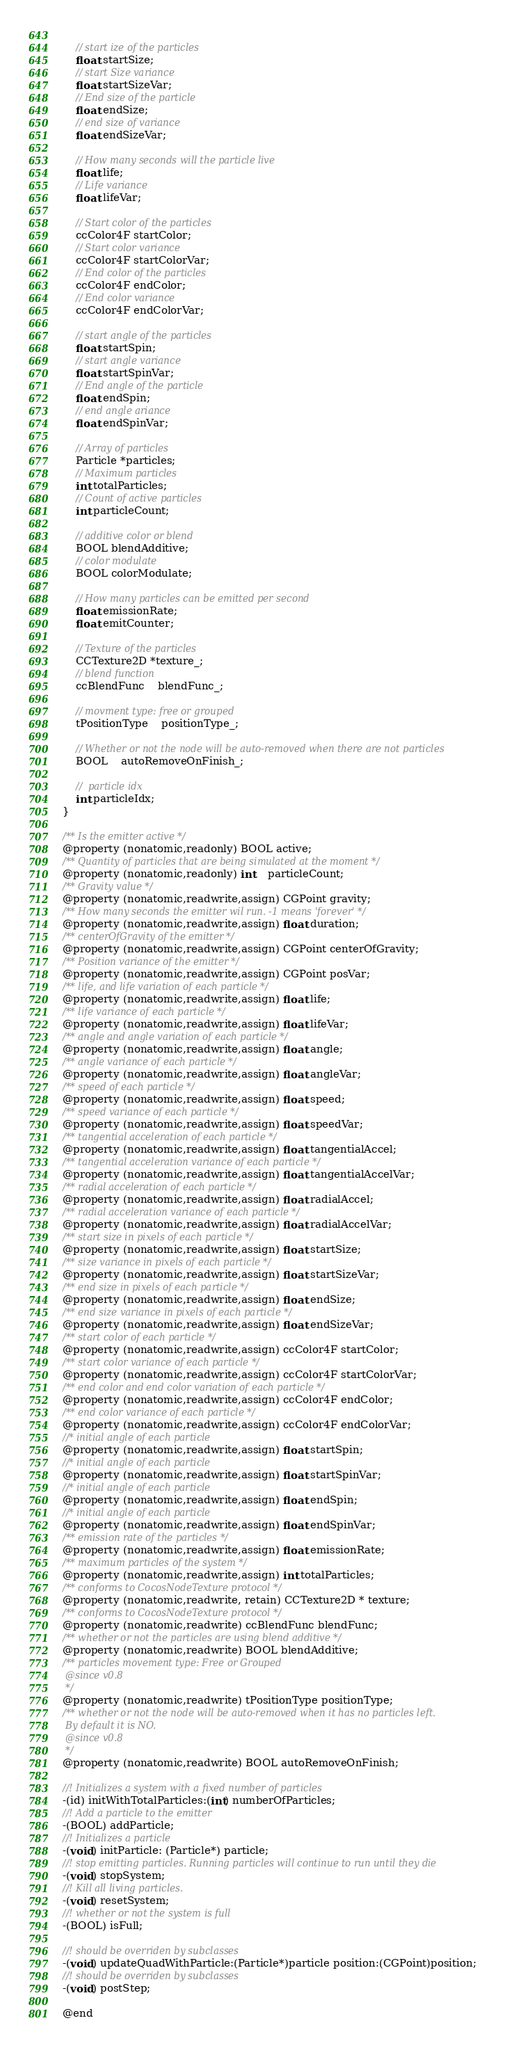<code> <loc_0><loc_0><loc_500><loc_500><_C_>	
	// start ize of the particles
	float startSize;
	// start Size variance
	float startSizeVar;
	// End size of the particle
	float endSize;
	// end size of variance
	float endSizeVar;
	
	// How many seconds will the particle live
	float life;
	// Life variance
	float lifeVar;
	
	// Start color of the particles
	ccColor4F startColor;
	// Start color variance
	ccColor4F startColorVar;
	// End color of the particles
	ccColor4F endColor;
	// End color variance
	ccColor4F endColorVar;
	
	// start angle of the particles
	float startSpin;
	// start angle variance
	float startSpinVar;
	// End angle of the particle
	float endSpin;
	// end angle ariance
	float endSpinVar;	
	
	// Array of particles
	Particle *particles;
	// Maximum particles
	int totalParticles;
	// Count of active particles
	int particleCount;
	
	// additive color or blend
	BOOL blendAdditive;
	// color modulate
	BOOL colorModulate;
	
	// How many particles can be emitted per second
	float emissionRate;
	float emitCounter;
	
	// Texture of the particles
	CCTexture2D *texture_;
	// blend function
	ccBlendFunc	blendFunc_;

	// movment type: free or grouped
	tPositionType	positionType_;

	// Whether or not the node will be auto-removed when there are not particles
	BOOL	autoRemoveOnFinish_;

	//  particle idx
	int particleIdx;
}

/** Is the emitter active */
@property (nonatomic,readonly) BOOL active;
/** Quantity of particles that are being simulated at the moment */
@property (nonatomic,readonly) int	particleCount;
/** Gravity value */
@property (nonatomic,readwrite,assign) CGPoint gravity;
/** How many seconds the emitter wil run. -1 means 'forever' */
@property (nonatomic,readwrite,assign) float duration;
/** centerOfGravity of the emitter */
@property (nonatomic,readwrite,assign) CGPoint centerOfGravity;
/** Position variance of the emitter */
@property (nonatomic,readwrite,assign) CGPoint posVar;
/** life, and life variation of each particle */
@property (nonatomic,readwrite,assign) float life;
/** life variance of each particle */
@property (nonatomic,readwrite,assign) float lifeVar;
/** angle and angle variation of each particle */
@property (nonatomic,readwrite,assign) float angle;
/** angle variance of each particle */
@property (nonatomic,readwrite,assign) float angleVar;
/** speed of each particle */
@property (nonatomic,readwrite,assign) float speed;
/** speed variance of each particle */
@property (nonatomic,readwrite,assign) float speedVar;
/** tangential acceleration of each particle */
@property (nonatomic,readwrite,assign) float tangentialAccel;
/** tangential acceleration variance of each particle */
@property (nonatomic,readwrite,assign) float tangentialAccelVar;
/** radial acceleration of each particle */
@property (nonatomic,readwrite,assign) float radialAccel;
/** radial acceleration variance of each particle */
@property (nonatomic,readwrite,assign) float radialAccelVar;
/** start size in pixels of each particle */
@property (nonatomic,readwrite,assign) float startSize;
/** size variance in pixels of each particle */
@property (nonatomic,readwrite,assign) float startSizeVar;
/** end size in pixels of each particle */
@property (nonatomic,readwrite,assign) float endSize;
/** end size variance in pixels of each particle */
@property (nonatomic,readwrite,assign) float endSizeVar;
/** start color of each particle */
@property (nonatomic,readwrite,assign) ccColor4F startColor;
/** start color variance of each particle */
@property (nonatomic,readwrite,assign) ccColor4F startColorVar;
/** end color and end color variation of each particle */
@property (nonatomic,readwrite,assign) ccColor4F endColor;
/** end color variance of each particle */
@property (nonatomic,readwrite,assign) ccColor4F endColorVar;
//* initial angle of each particle
@property (nonatomic,readwrite,assign) float startSpin;
//* initial angle of each particle
@property (nonatomic,readwrite,assign) float startSpinVar;
//* initial angle of each particle
@property (nonatomic,readwrite,assign) float endSpin;
//* initial angle of each particle
@property (nonatomic,readwrite,assign) float endSpinVar;
/** emission rate of the particles */
@property (nonatomic,readwrite,assign) float emissionRate;
/** maximum particles of the system */
@property (nonatomic,readwrite,assign) int totalParticles;
/** conforms to CocosNodeTexture protocol */
@property (nonatomic,readwrite, retain) CCTexture2D * texture;
/** conforms to CocosNodeTexture protocol */
@property (nonatomic,readwrite) ccBlendFunc blendFunc;
/** whether or not the particles are using blend additive */
@property (nonatomic,readwrite) BOOL blendAdditive;
/** particles movement type: Free or Grouped
 @since v0.8
 */
@property (nonatomic,readwrite) tPositionType positionType;
/** whether or not the node will be auto-removed when it has no particles left.
 By default it is NO.
 @since v0.8
 */
@property (nonatomic,readwrite) BOOL autoRemoveOnFinish;

//! Initializes a system with a fixed number of particles
-(id) initWithTotalParticles:(int) numberOfParticles;
//! Add a particle to the emitter
-(BOOL) addParticle;
//! Initializes a particle
-(void) initParticle: (Particle*) particle;
//! stop emitting particles. Running particles will continue to run until they die
-(void) stopSystem;
//! Kill all living particles.
-(void) resetSystem;
//! whether or not the system is full
-(BOOL) isFull;

//! should be overriden by subclasses
-(void) updateQuadWithParticle:(Particle*)particle position:(CGPoint)position;
//! should be overriden by subclasses
-(void) postStep;

@end

</code> 